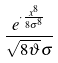<formula> <loc_0><loc_0><loc_500><loc_500>\frac { e ^ { \cdot \frac { x ^ { 8 } } { 8 \sigma ^ { 8 } } } } { \sqrt { 8 \vartheta } \sigma }</formula> 